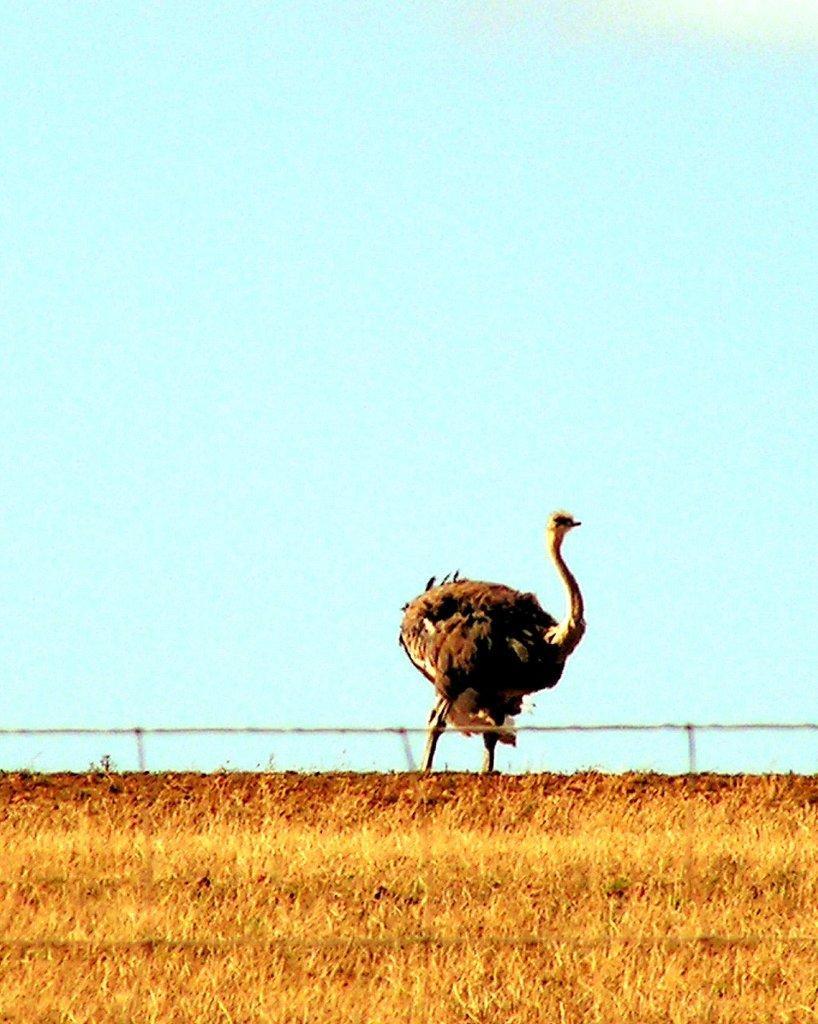How would you summarize this image in a sentence or two? In this picture we can see grass at the bottom, there is an ostrich standing in the middle, we can see the sky in the background. 